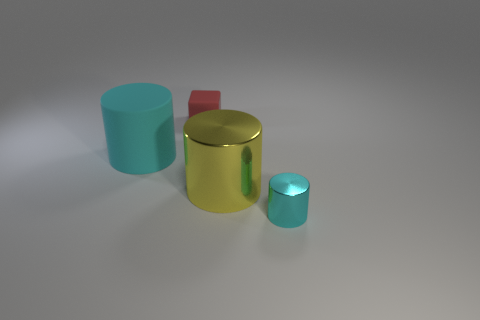Do the big cylinder that is to the left of the rubber cube and the red thing have the same material?
Offer a terse response. Yes. There is a thing that is on the left side of the big yellow metal cylinder and in front of the red rubber block; what is its material?
Provide a succinct answer. Rubber. What size is the metallic thing that is the same color as the matte cylinder?
Ensure brevity in your answer.  Small. There is a cyan thing in front of the large thing that is left of the large shiny cylinder; what is it made of?
Your answer should be very brief. Metal. There is a metallic cylinder in front of the big object that is right of the cyan cylinder that is on the left side of the tiny red matte block; how big is it?
Offer a terse response. Small. How many small cylinders have the same material as the big yellow cylinder?
Provide a short and direct response. 1. There is a metallic cylinder behind the cyan cylinder in front of the cyan matte cylinder; what is its color?
Ensure brevity in your answer.  Yellow. What number of objects are big red metal blocks or things on the left side of the yellow metal thing?
Provide a succinct answer. 2. Are there any small metal cylinders that have the same color as the matte cylinder?
Offer a terse response. Yes. What number of brown objects are either cubes or big matte objects?
Ensure brevity in your answer.  0. 